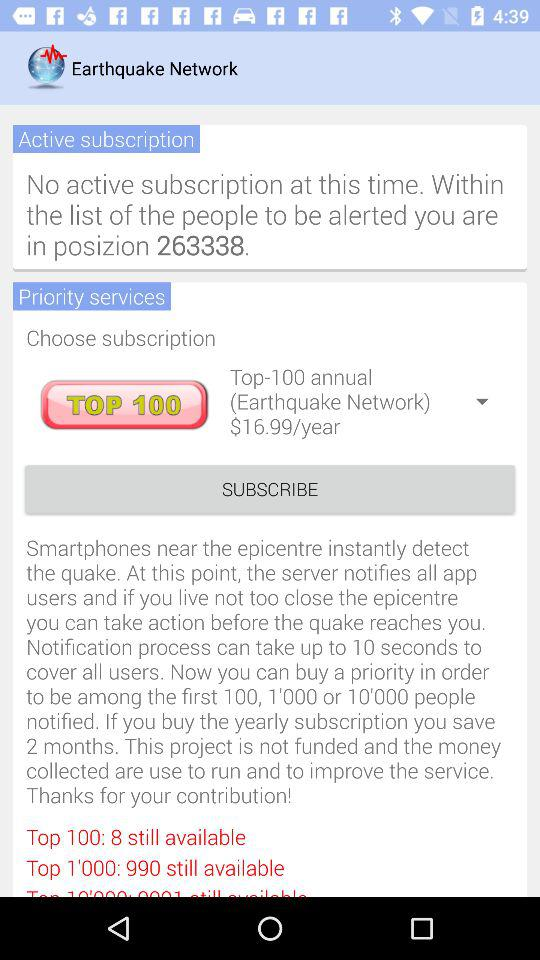What is the annual subscription cost of the Top 100? The annual subscription cost is $16.99. 